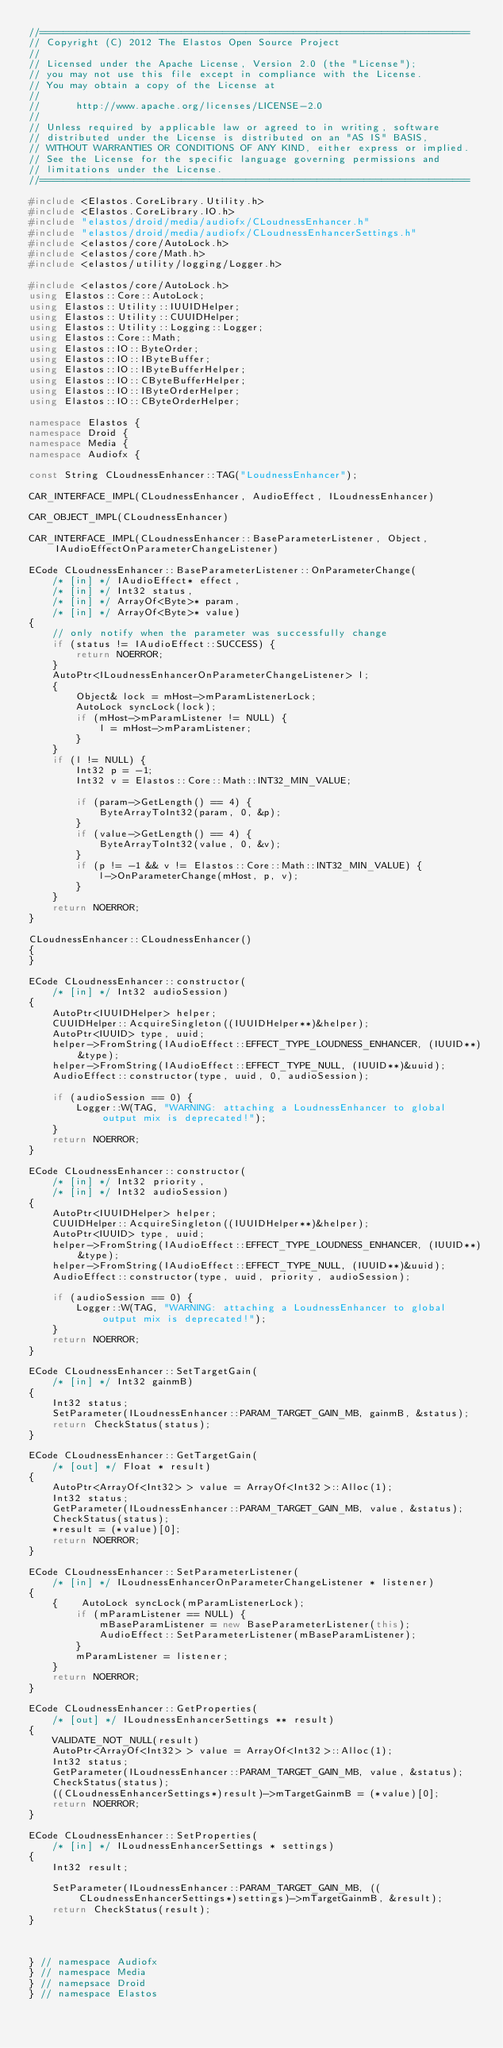<code> <loc_0><loc_0><loc_500><loc_500><_C++_>//=========================================================================
// Copyright (C) 2012 The Elastos Open Source Project
//
// Licensed under the Apache License, Version 2.0 (the "License");
// you may not use this file except in compliance with the License.
// You may obtain a copy of the License at
//
//      http://www.apache.org/licenses/LICENSE-2.0
//
// Unless required by applicable law or agreed to in writing, software
// distributed under the License is distributed on an "AS IS" BASIS,
// WITHOUT WARRANTIES OR CONDITIONS OF ANY KIND, either express or implied.
// See the License for the specific language governing permissions and
// limitations under the License.
//=========================================================================

#include <Elastos.CoreLibrary.Utility.h>
#include <Elastos.CoreLibrary.IO.h>
#include "elastos/droid/media/audiofx/CLoudnessEnhancer.h"
#include "elastos/droid/media/audiofx/CLoudnessEnhancerSettings.h"
#include <elastos/core/AutoLock.h>
#include <elastos/core/Math.h>
#include <elastos/utility/logging/Logger.h>

#include <elastos/core/AutoLock.h>
using Elastos::Core::AutoLock;
using Elastos::Utility::IUUIDHelper;
using Elastos::Utility::CUUIDHelper;
using Elastos::Utility::Logging::Logger;
using Elastos::Core::Math;
using Elastos::IO::ByteOrder;
using Elastos::IO::IByteBuffer;
using Elastos::IO::IByteBufferHelper;
using Elastos::IO::CByteBufferHelper;
using Elastos::IO::IByteOrderHelper;
using Elastos::IO::CByteOrderHelper;

namespace Elastos {
namespace Droid {
namespace Media {
namespace Audiofx {

const String CLoudnessEnhancer::TAG("LoudnessEnhancer");

CAR_INTERFACE_IMPL(CLoudnessEnhancer, AudioEffect, ILoudnessEnhancer)

CAR_OBJECT_IMPL(CLoudnessEnhancer)

CAR_INTERFACE_IMPL(CLoudnessEnhancer::BaseParameterListener, Object, IAudioEffectOnParameterChangeListener)

ECode CLoudnessEnhancer::BaseParameterListener::OnParameterChange(
    /* [in] */ IAudioEffect* effect,
    /* [in] */ Int32 status,
    /* [in] */ ArrayOf<Byte>* param,
    /* [in] */ ArrayOf<Byte>* value)
{
    // only notify when the parameter was successfully change
    if (status != IAudioEffect::SUCCESS) {
        return NOERROR;
    }
    AutoPtr<ILoudnessEnhancerOnParameterChangeListener> l;
    {
        Object& lock = mHost->mParamListenerLock;
        AutoLock syncLock(lock);
        if (mHost->mParamListener != NULL) {
            l = mHost->mParamListener;
        }
    }
    if (l != NULL) {
        Int32 p = -1;
        Int32 v = Elastos::Core::Math::INT32_MIN_VALUE;

        if (param->GetLength() == 4) {
            ByteArrayToInt32(param, 0, &p);
        }
        if (value->GetLength() == 4) {
            ByteArrayToInt32(value, 0, &v);
        }
        if (p != -1 && v != Elastos::Core::Math::INT32_MIN_VALUE) {
            l->OnParameterChange(mHost, p, v);
        }
    }
    return NOERROR;
}

CLoudnessEnhancer::CLoudnessEnhancer()
{
}

ECode CLoudnessEnhancer::constructor(
    /* [in] */ Int32 audioSession)
{
    AutoPtr<IUUIDHelper> helper;
    CUUIDHelper::AcquireSingleton((IUUIDHelper**)&helper);
    AutoPtr<IUUID> type, uuid;
    helper->FromString(IAudioEffect::EFFECT_TYPE_LOUDNESS_ENHANCER, (IUUID**)&type);
    helper->FromString(IAudioEffect::EFFECT_TYPE_NULL, (IUUID**)&uuid);
    AudioEffect::constructor(type, uuid, 0, audioSession);

    if (audioSession == 0) {
        Logger::W(TAG, "WARNING: attaching a LoudnessEnhancer to global output mix is deprecated!");
    }
    return NOERROR;
}

ECode CLoudnessEnhancer::constructor(
    /* [in] */ Int32 priority,
    /* [in] */ Int32 audioSession)
{
    AutoPtr<IUUIDHelper> helper;
    CUUIDHelper::AcquireSingleton((IUUIDHelper**)&helper);
    AutoPtr<IUUID> type, uuid;
    helper->FromString(IAudioEffect::EFFECT_TYPE_LOUDNESS_ENHANCER, (IUUID**)&type);
    helper->FromString(IAudioEffect::EFFECT_TYPE_NULL, (IUUID**)&uuid);
    AudioEffect::constructor(type, uuid, priority, audioSession);

    if (audioSession == 0) {
        Logger::W(TAG, "WARNING: attaching a LoudnessEnhancer to global output mix is deprecated!");
    }
    return NOERROR;
}

ECode CLoudnessEnhancer::SetTargetGain(
    /* [in] */ Int32 gainmB)
{
    Int32 status;
    SetParameter(ILoudnessEnhancer::PARAM_TARGET_GAIN_MB, gainmB, &status);
    return CheckStatus(status);
}

ECode CLoudnessEnhancer::GetTargetGain(
    /* [out] */ Float * result)
{
    AutoPtr<ArrayOf<Int32> > value = ArrayOf<Int32>::Alloc(1);
    Int32 status;
    GetParameter(ILoudnessEnhancer::PARAM_TARGET_GAIN_MB, value, &status);
    CheckStatus(status);
    *result = (*value)[0];
    return NOERROR;
}

ECode CLoudnessEnhancer::SetParameterListener(
    /* [in] */ ILoudnessEnhancerOnParameterChangeListener * listener)
{
    {    AutoLock syncLock(mParamListenerLock);
        if (mParamListener == NULL) {
            mBaseParamListener = new BaseParameterListener(this);
            AudioEffect::SetParameterListener(mBaseParamListener);
        }
        mParamListener = listener;
    }
    return NOERROR;
}

ECode CLoudnessEnhancer::GetProperties(
    /* [out] */ ILoudnessEnhancerSettings ** result)
{
    VALIDATE_NOT_NULL(result)
    AutoPtr<ArrayOf<Int32> > value = ArrayOf<Int32>::Alloc(1);
    Int32 status;
    GetParameter(ILoudnessEnhancer::PARAM_TARGET_GAIN_MB, value, &status);
    CheckStatus(status);
    ((CLoudnessEnhancerSettings*)result)->mTargetGainmB = (*value)[0];
    return NOERROR;
}

ECode CLoudnessEnhancer::SetProperties(
    /* [in] */ ILoudnessEnhancerSettings * settings)
{
    Int32 result;

    SetParameter(ILoudnessEnhancer::PARAM_TARGET_GAIN_MB, ((CLoudnessEnhancerSettings*)settings)->mTargetGainmB, &result);
    return CheckStatus(result);
}



} // namespace Audiofx
} // namespace Media
} // namepsace Droid
} // namespace Elastos
</code> 